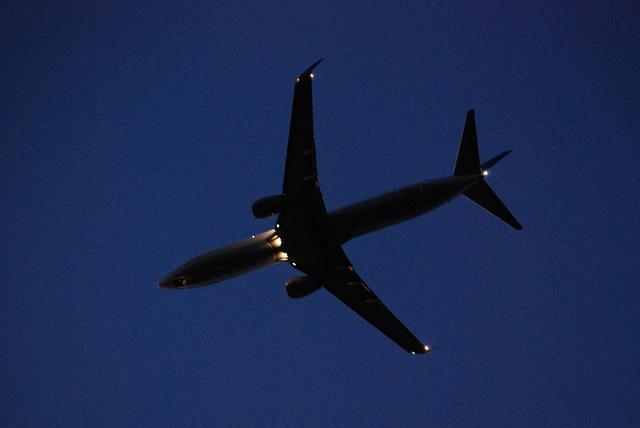Can you see details on the plane?
Short answer required. No. Is that the shadow of the plane or a bird?
Give a very brief answer. Plane. Is the picture taken at night time or day time?
Short answer required. Night. Does the airplane seem high up?
Answer briefly. Yes. Was this picture taken at 2 pm?
Quick response, please. No. 